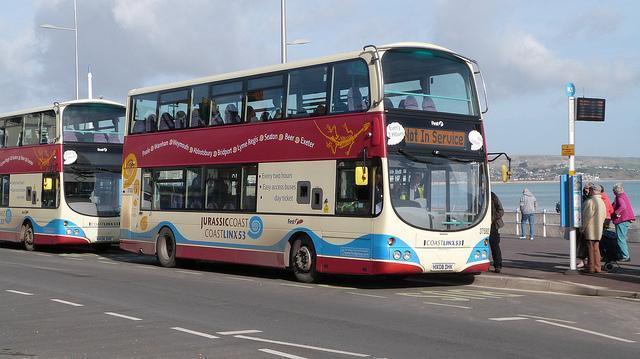How many buses in the picture?
Give a very brief answer. 2. How many decks does the bus have?
Give a very brief answer. 2. How many buses are in the photo?
Give a very brief answer. 2. 